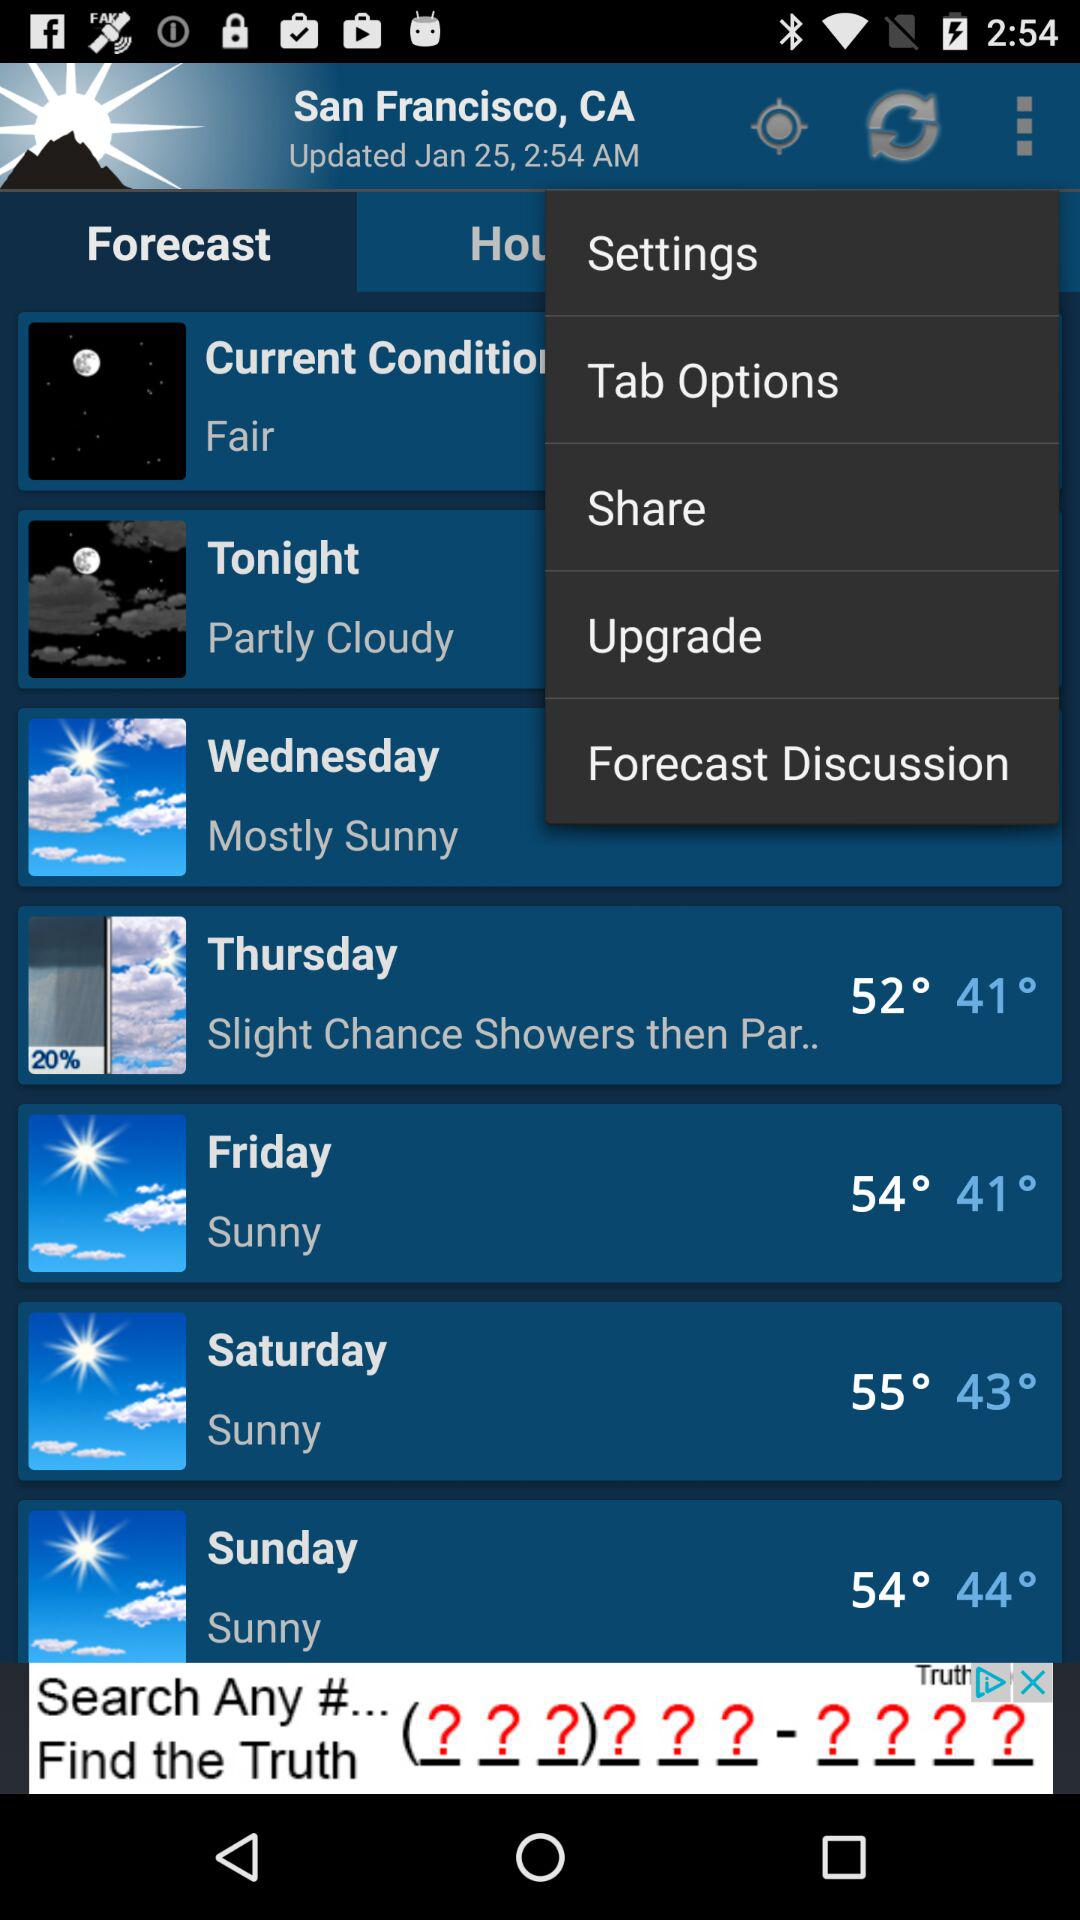How is the weather on Sunday? The weather on Sunday is sunny. 